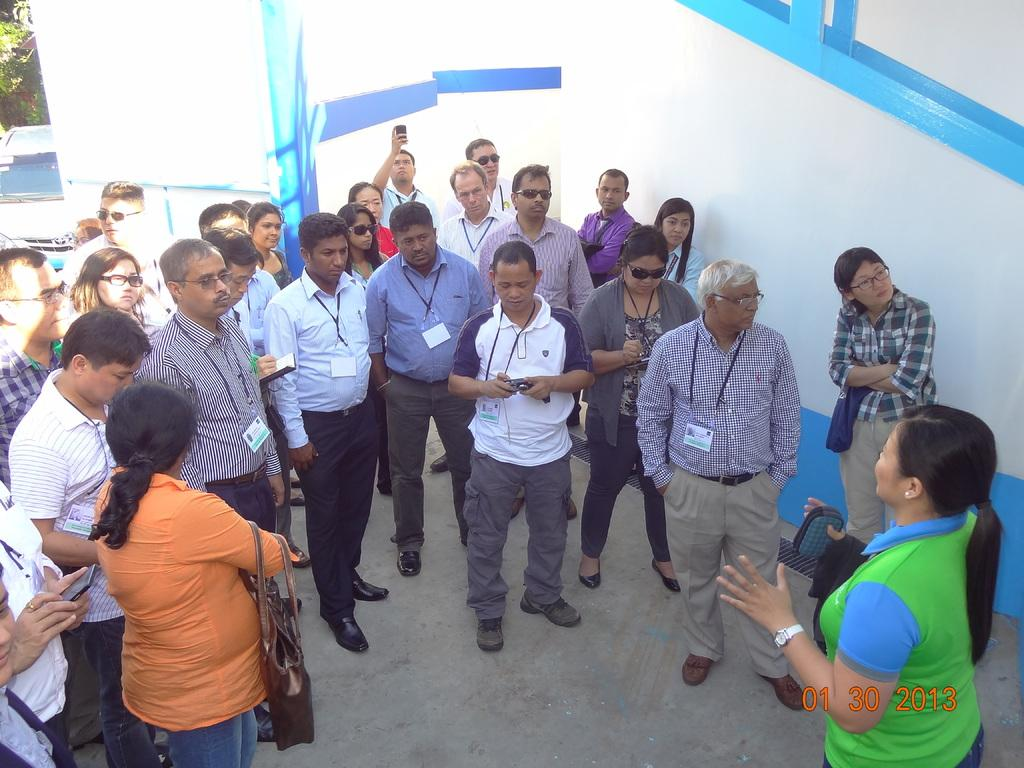What are the people in the image doing? The people in the image are standing on the ground. What are some of the people holding? Some of the people are holding objects. What can be seen in the background of the image? There is a car, trees, and a wall in the background. What type of silk is being displayed in the image? There is no silk present in the image. What show are the people attending in the image? There is no indication of a show or event in the image. 